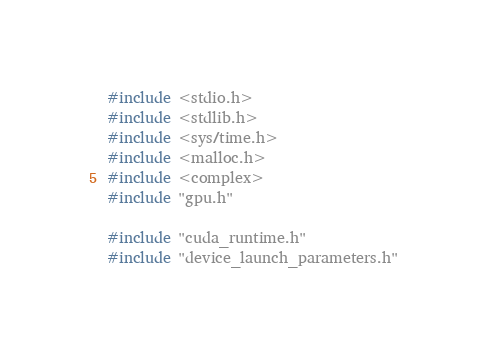Convert code to text. <code><loc_0><loc_0><loc_500><loc_500><_Cuda_>#include <stdio.h>
#include <stdlib.h>
#include <sys/time.h>
#include <malloc.h>
#include <complex>
#include "gpu.h"

#include "cuda_runtime.h"
#include "device_launch_parameters.h"</code> 